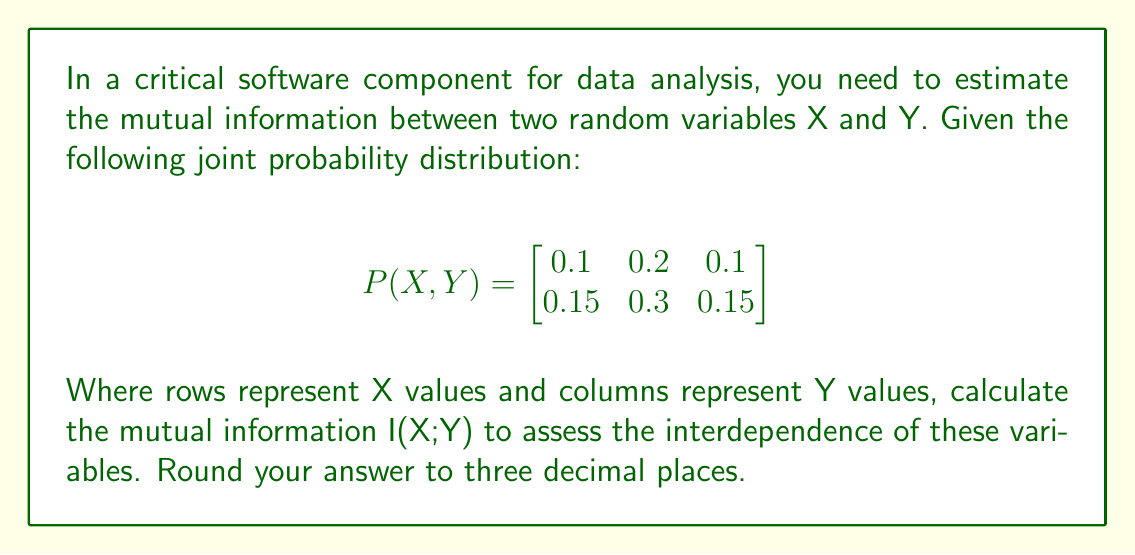Teach me how to tackle this problem. To calculate the mutual information I(X;Y), we'll follow these steps:

1. Calculate marginal probabilities P(X) and P(Y):
   P(X=0) = 0.1 + 0.2 + 0.1 = 0.4
   P(X=1) = 0.15 + 0.3 + 0.15 = 0.6
   P(Y=0) = 0.1 + 0.15 = 0.25
   P(Y=1) = 0.2 + 0.3 = 0.5
   P(Y=2) = 0.1 + 0.15 = 0.25

2. Use the formula for mutual information:
   $$I(X;Y) = \sum_{x}\sum_{y} P(x,y) \log_2\frac{P(x,y)}{P(x)P(y)}$$

3. Calculate each term:
   $$\begin{aligned}
   0.1 \log_2\frac{0.1}{0.4 \cdot 0.25} &= 0.1 \log_2 1 = 0 \\
   0.2 \log_2\frac{0.2}{0.4 \cdot 0.5} &= 0.2 \log_2 1 = 0 \\
   0.1 \log_2\frac{0.1}{0.4 \cdot 0.25} &= 0.1 \log_2 1 = 0 \\
   0.15 \log_2\frac{0.15}{0.6 \cdot 0.25} &\approx 0.0223 \\
   0.3 \log_2\frac{0.3}{0.6 \cdot 0.5} &= 0.3 \log_2 1 = 0 \\
   0.15 \log_2\frac{0.15}{0.6 \cdot 0.25} &\approx 0.0223
   \end{aligned}$$

4. Sum all terms:
   $$I(X;Y) = 0 + 0 + 0 + 0.0223 + 0 + 0.0223 = 0.0446$$

5. Round to three decimal places:
   $$I(X;Y) \approx 0.045 \text{ bits}$$
Answer: 0.045 bits 